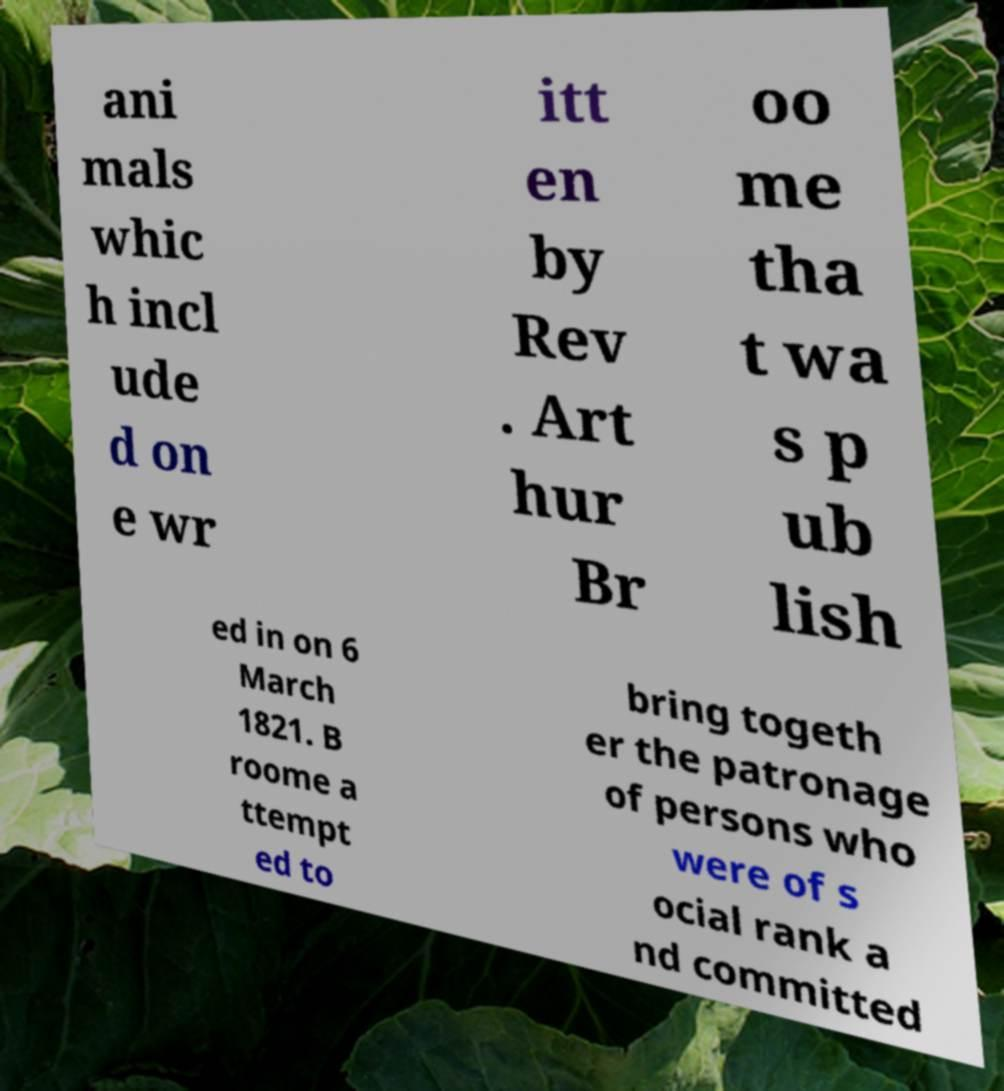I need the written content from this picture converted into text. Can you do that? ani mals whic h incl ude d on e wr itt en by Rev . Art hur Br oo me tha t wa s p ub lish ed in on 6 March 1821. B roome a ttempt ed to bring togeth er the patronage of persons who were of s ocial rank a nd committed 